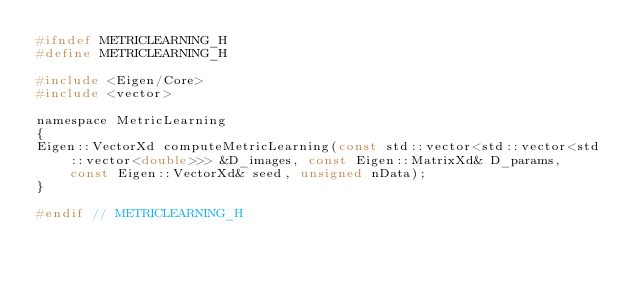<code> <loc_0><loc_0><loc_500><loc_500><_C_>#ifndef METRICLEARNING_H
#define METRICLEARNING_H

#include <Eigen/Core>
#include <vector>

namespace MetricLearning
{
Eigen::VectorXd computeMetricLearning(const std::vector<std::vector<std::vector<double>>> &D_images, const Eigen::MatrixXd& D_params, const Eigen::VectorXd& seed, unsigned nData);
}

#endif // METRICLEARNING_H
</code> 